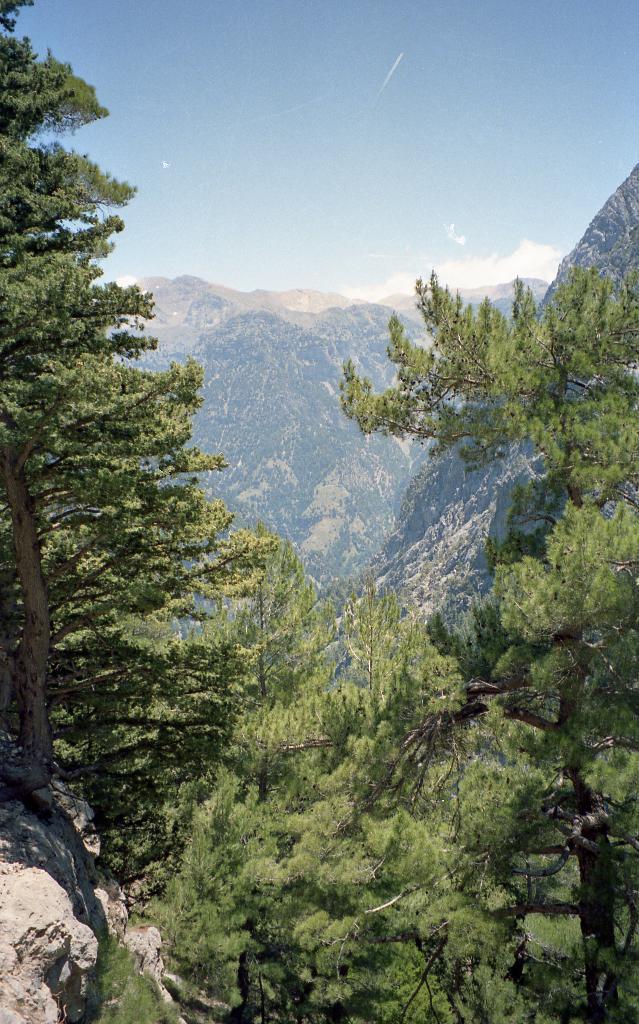Could you give a brief overview of what you see in this image? In this image we can see trees and mountains. In the background there is sky with clouds. 